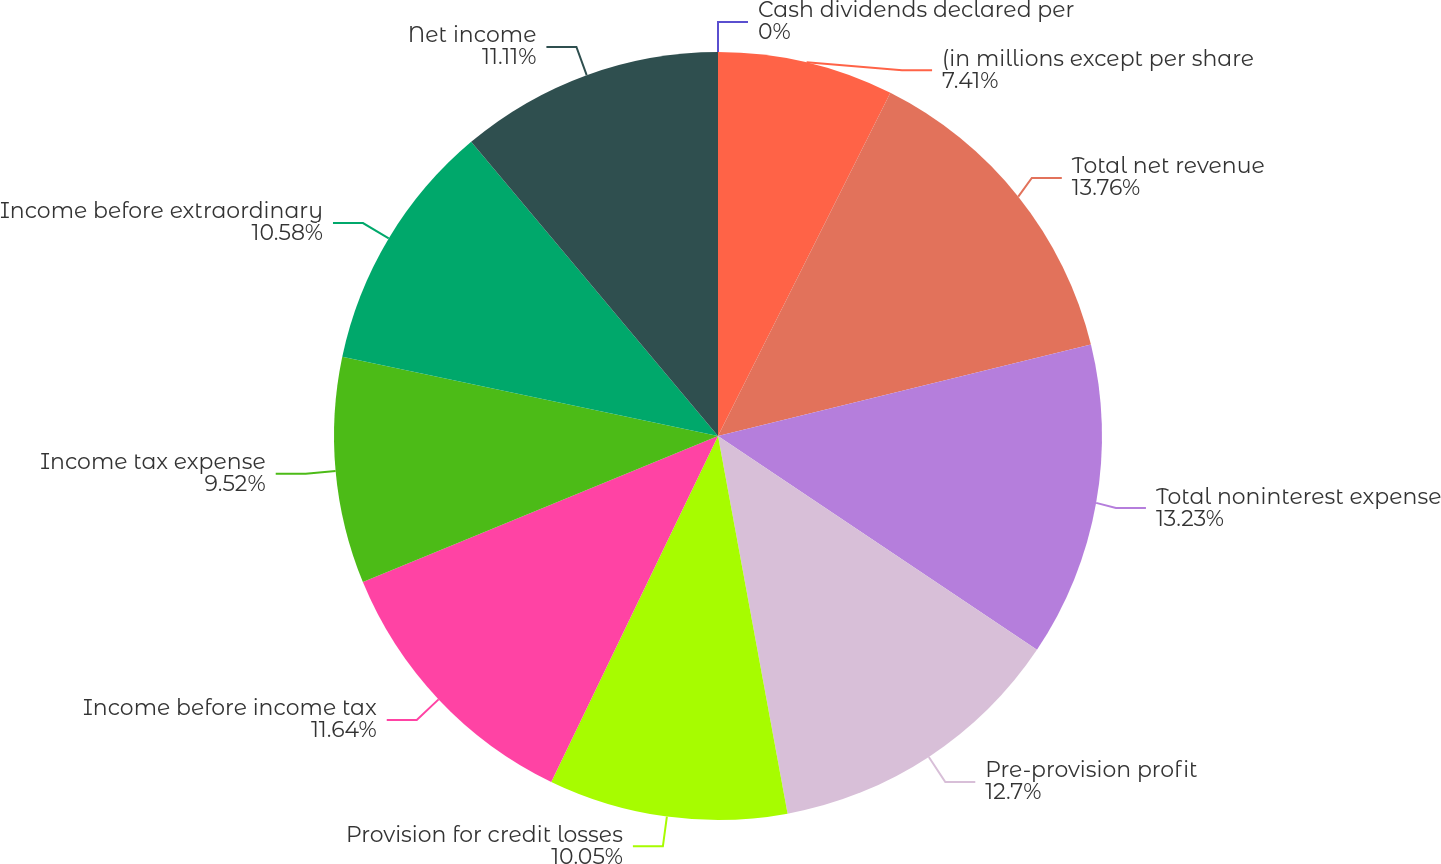Convert chart. <chart><loc_0><loc_0><loc_500><loc_500><pie_chart><fcel>(in millions except per share<fcel>Total net revenue<fcel>Total noninterest expense<fcel>Pre-provision profit<fcel>Provision for credit losses<fcel>Income before income tax<fcel>Income tax expense<fcel>Income before extraordinary<fcel>Net income<fcel>Cash dividends declared per<nl><fcel>7.41%<fcel>13.76%<fcel>13.23%<fcel>12.7%<fcel>10.05%<fcel>11.64%<fcel>9.52%<fcel>10.58%<fcel>11.11%<fcel>0.0%<nl></chart> 